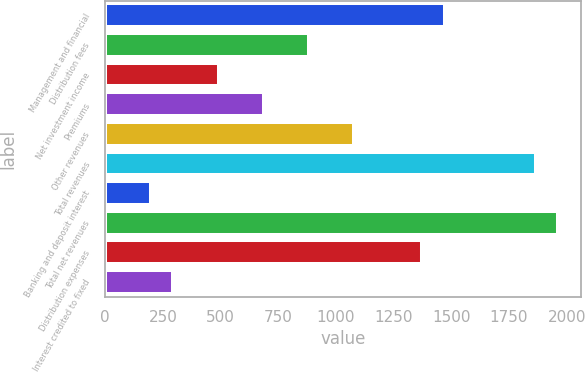Convert chart to OTSL. <chart><loc_0><loc_0><loc_500><loc_500><bar_chart><fcel>Management and financial<fcel>Distribution fees<fcel>Net investment income<fcel>Premiums<fcel>Other revenues<fcel>Total revenues<fcel>Banking and deposit interest<fcel>Total net revenues<fcel>Distribution expenses<fcel>Interest credited to fixed<nl><fcel>1472.5<fcel>883.9<fcel>491.5<fcel>687.7<fcel>1080.1<fcel>1864.9<fcel>197.2<fcel>1963<fcel>1374.4<fcel>295.3<nl></chart> 